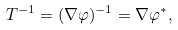<formula> <loc_0><loc_0><loc_500><loc_500>T ^ { - 1 } = ( \nabla \varphi ) ^ { - 1 } = \nabla \varphi ^ { * } ,</formula> 